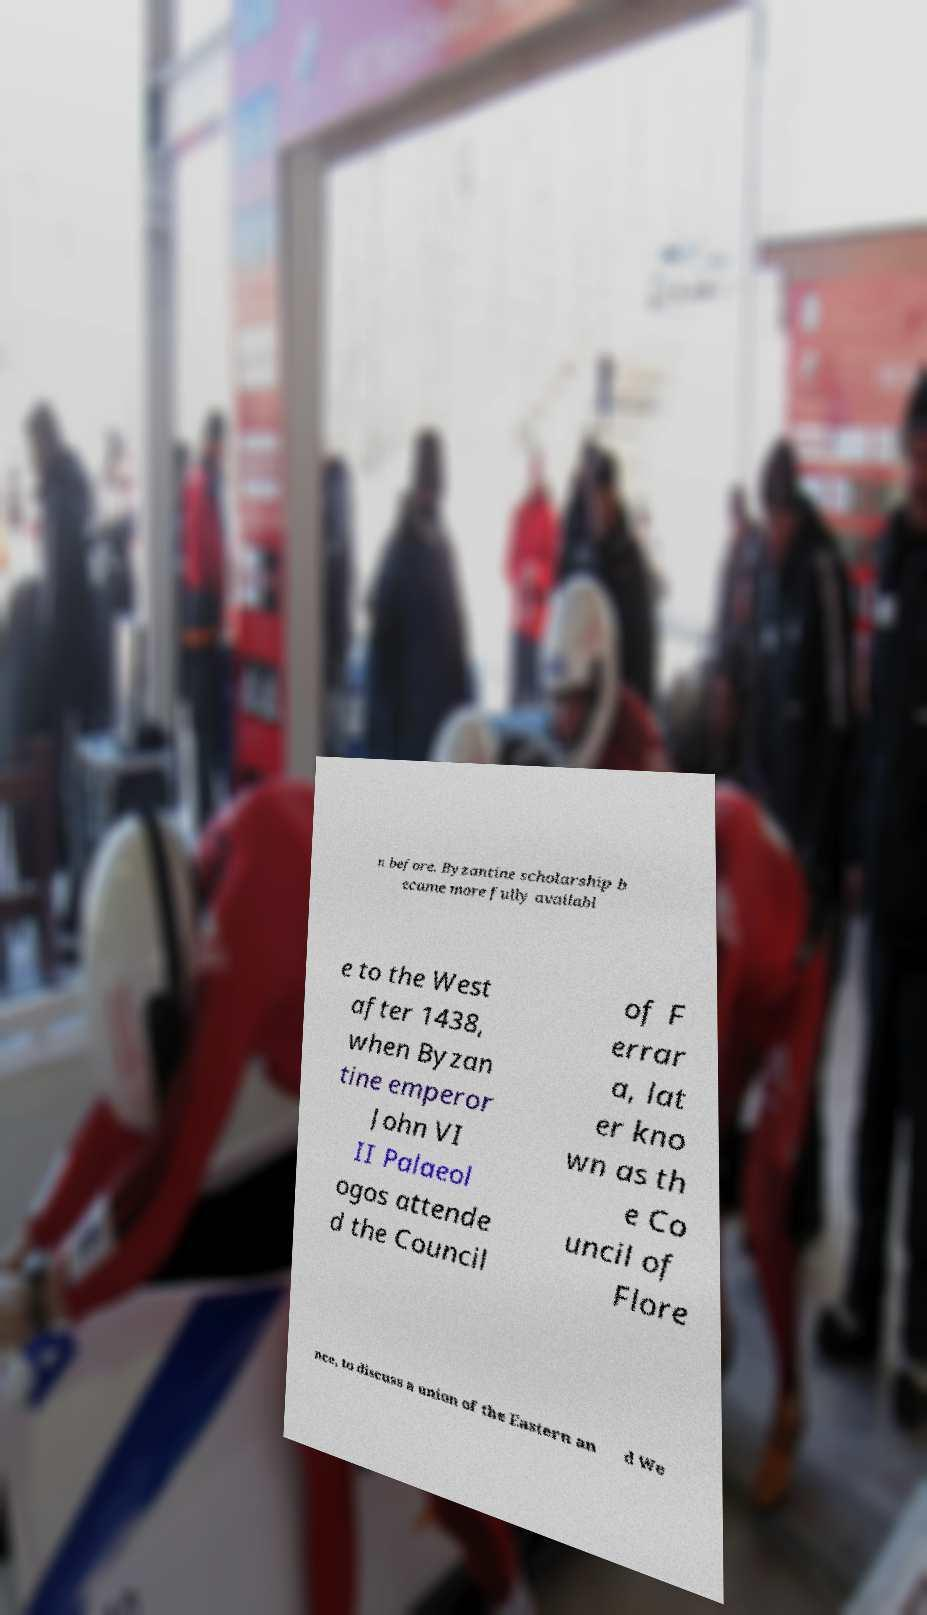Could you assist in decoding the text presented in this image and type it out clearly? n before. Byzantine scholarship b ecame more fully availabl e to the West after 1438, when Byzan tine emperor John VI II Palaeol ogos attende d the Council of F errar a, lat er kno wn as th e Co uncil of Flore nce, to discuss a union of the Eastern an d We 